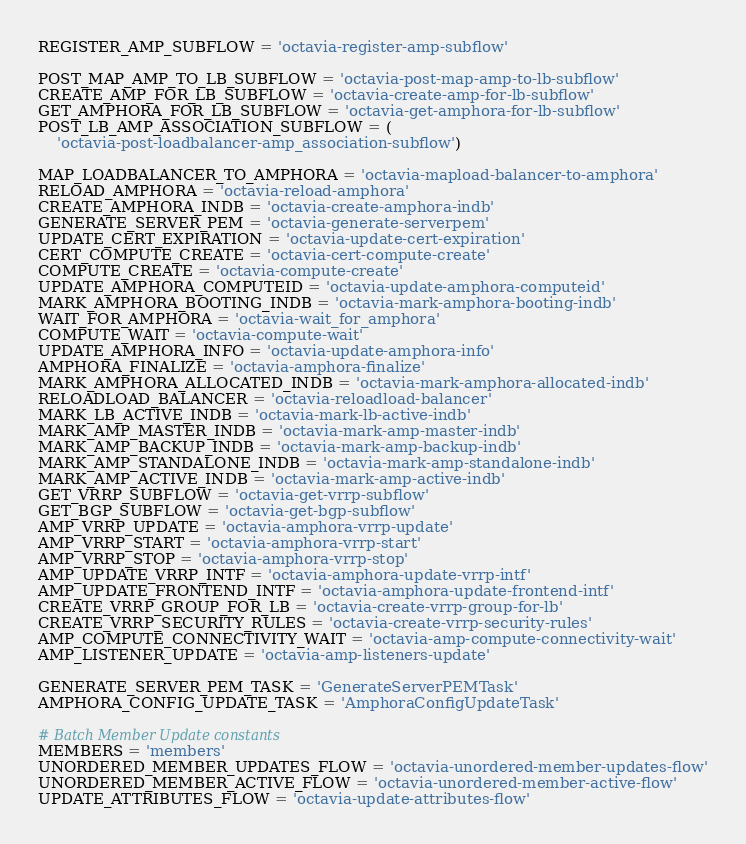<code> <loc_0><loc_0><loc_500><loc_500><_Python_>REGISTER_AMP_SUBFLOW = 'octavia-register-amp-subflow'

POST_MAP_AMP_TO_LB_SUBFLOW = 'octavia-post-map-amp-to-lb-subflow'
CREATE_AMP_FOR_LB_SUBFLOW = 'octavia-create-amp-for-lb-subflow'
GET_AMPHORA_FOR_LB_SUBFLOW = 'octavia-get-amphora-for-lb-subflow'
POST_LB_AMP_ASSOCIATION_SUBFLOW = (
    'octavia-post-loadbalancer-amp_association-subflow')

MAP_LOADBALANCER_TO_AMPHORA = 'octavia-mapload-balancer-to-amphora'
RELOAD_AMPHORA = 'octavia-reload-amphora'
CREATE_AMPHORA_INDB = 'octavia-create-amphora-indb'
GENERATE_SERVER_PEM = 'octavia-generate-serverpem'
UPDATE_CERT_EXPIRATION = 'octavia-update-cert-expiration'
CERT_COMPUTE_CREATE = 'octavia-cert-compute-create'
COMPUTE_CREATE = 'octavia-compute-create'
UPDATE_AMPHORA_COMPUTEID = 'octavia-update-amphora-computeid'
MARK_AMPHORA_BOOTING_INDB = 'octavia-mark-amphora-booting-indb'
WAIT_FOR_AMPHORA = 'octavia-wait_for_amphora'
COMPUTE_WAIT = 'octavia-compute-wait'
UPDATE_AMPHORA_INFO = 'octavia-update-amphora-info'
AMPHORA_FINALIZE = 'octavia-amphora-finalize'
MARK_AMPHORA_ALLOCATED_INDB = 'octavia-mark-amphora-allocated-indb'
RELOADLOAD_BALANCER = 'octavia-reloadload-balancer'
MARK_LB_ACTIVE_INDB = 'octavia-mark-lb-active-indb'
MARK_AMP_MASTER_INDB = 'octavia-mark-amp-master-indb'
MARK_AMP_BACKUP_INDB = 'octavia-mark-amp-backup-indb'
MARK_AMP_STANDALONE_INDB = 'octavia-mark-amp-standalone-indb'
MARK_AMP_ACTIVE_INDB = 'octavia-mark-amp-active-indb'
GET_VRRP_SUBFLOW = 'octavia-get-vrrp-subflow'
GET_BGP_SUBFLOW = 'octavia-get-bgp-subflow'
AMP_VRRP_UPDATE = 'octavia-amphora-vrrp-update'
AMP_VRRP_START = 'octavia-amphora-vrrp-start'
AMP_VRRP_STOP = 'octavia-amphora-vrrp-stop'
AMP_UPDATE_VRRP_INTF = 'octavia-amphora-update-vrrp-intf'
AMP_UPDATE_FRONTEND_INTF = 'octavia-amphora-update-frontend-intf'
CREATE_VRRP_GROUP_FOR_LB = 'octavia-create-vrrp-group-for-lb'
CREATE_VRRP_SECURITY_RULES = 'octavia-create-vrrp-security-rules'
AMP_COMPUTE_CONNECTIVITY_WAIT = 'octavia-amp-compute-connectivity-wait'
AMP_LISTENER_UPDATE = 'octavia-amp-listeners-update'

GENERATE_SERVER_PEM_TASK = 'GenerateServerPEMTask'
AMPHORA_CONFIG_UPDATE_TASK = 'AmphoraConfigUpdateTask'

# Batch Member Update constants
MEMBERS = 'members'
UNORDERED_MEMBER_UPDATES_FLOW = 'octavia-unordered-member-updates-flow'
UNORDERED_MEMBER_ACTIVE_FLOW = 'octavia-unordered-member-active-flow'
UPDATE_ATTRIBUTES_FLOW = 'octavia-update-attributes-flow'</code> 